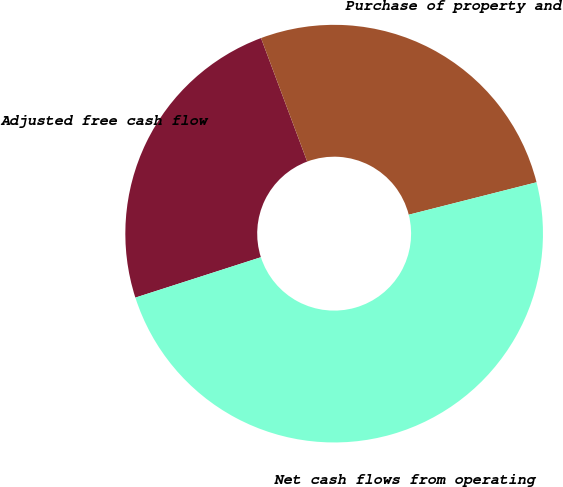Convert chart to OTSL. <chart><loc_0><loc_0><loc_500><loc_500><pie_chart><fcel>Adjusted free cash flow<fcel>Purchase of property and<fcel>Net cash flows from operating<nl><fcel>24.26%<fcel>26.74%<fcel>49.0%<nl></chart> 